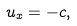<formula> <loc_0><loc_0><loc_500><loc_500>u _ { x } = - c ,</formula> 